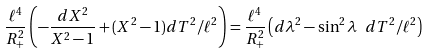Convert formula to latex. <formula><loc_0><loc_0><loc_500><loc_500>\frac { \ell ^ { 4 } } { R ^ { 2 } _ { + } } \left ( - \frac { d X ^ { 2 } } { X ^ { 2 } - 1 } + ( X ^ { 2 } - 1 ) d T ^ { 2 } / \ell ^ { 2 } \right ) = \frac { \ell ^ { 4 } } { R ^ { 2 } _ { + } } \left ( d \lambda ^ { 2 } - \sin ^ { 2 } \lambda \ d T ^ { 2 } / \ell ^ { 2 } \right )</formula> 